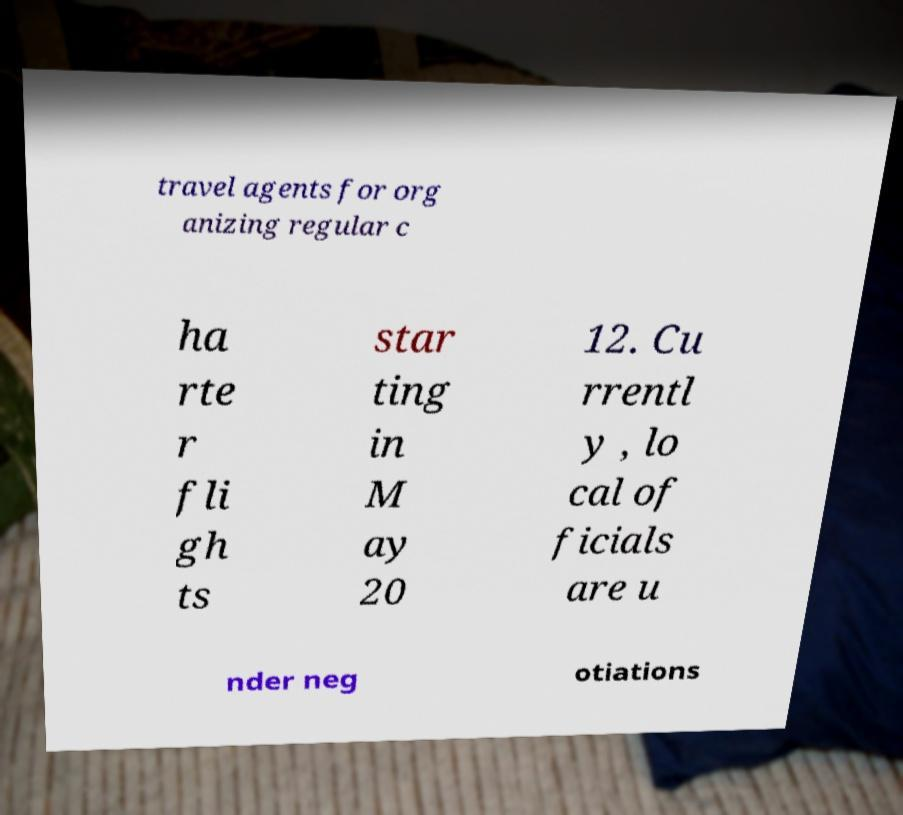Can you accurately transcribe the text from the provided image for me? travel agents for org anizing regular c ha rte r fli gh ts star ting in M ay 20 12. Cu rrentl y , lo cal of ficials are u nder neg otiations 